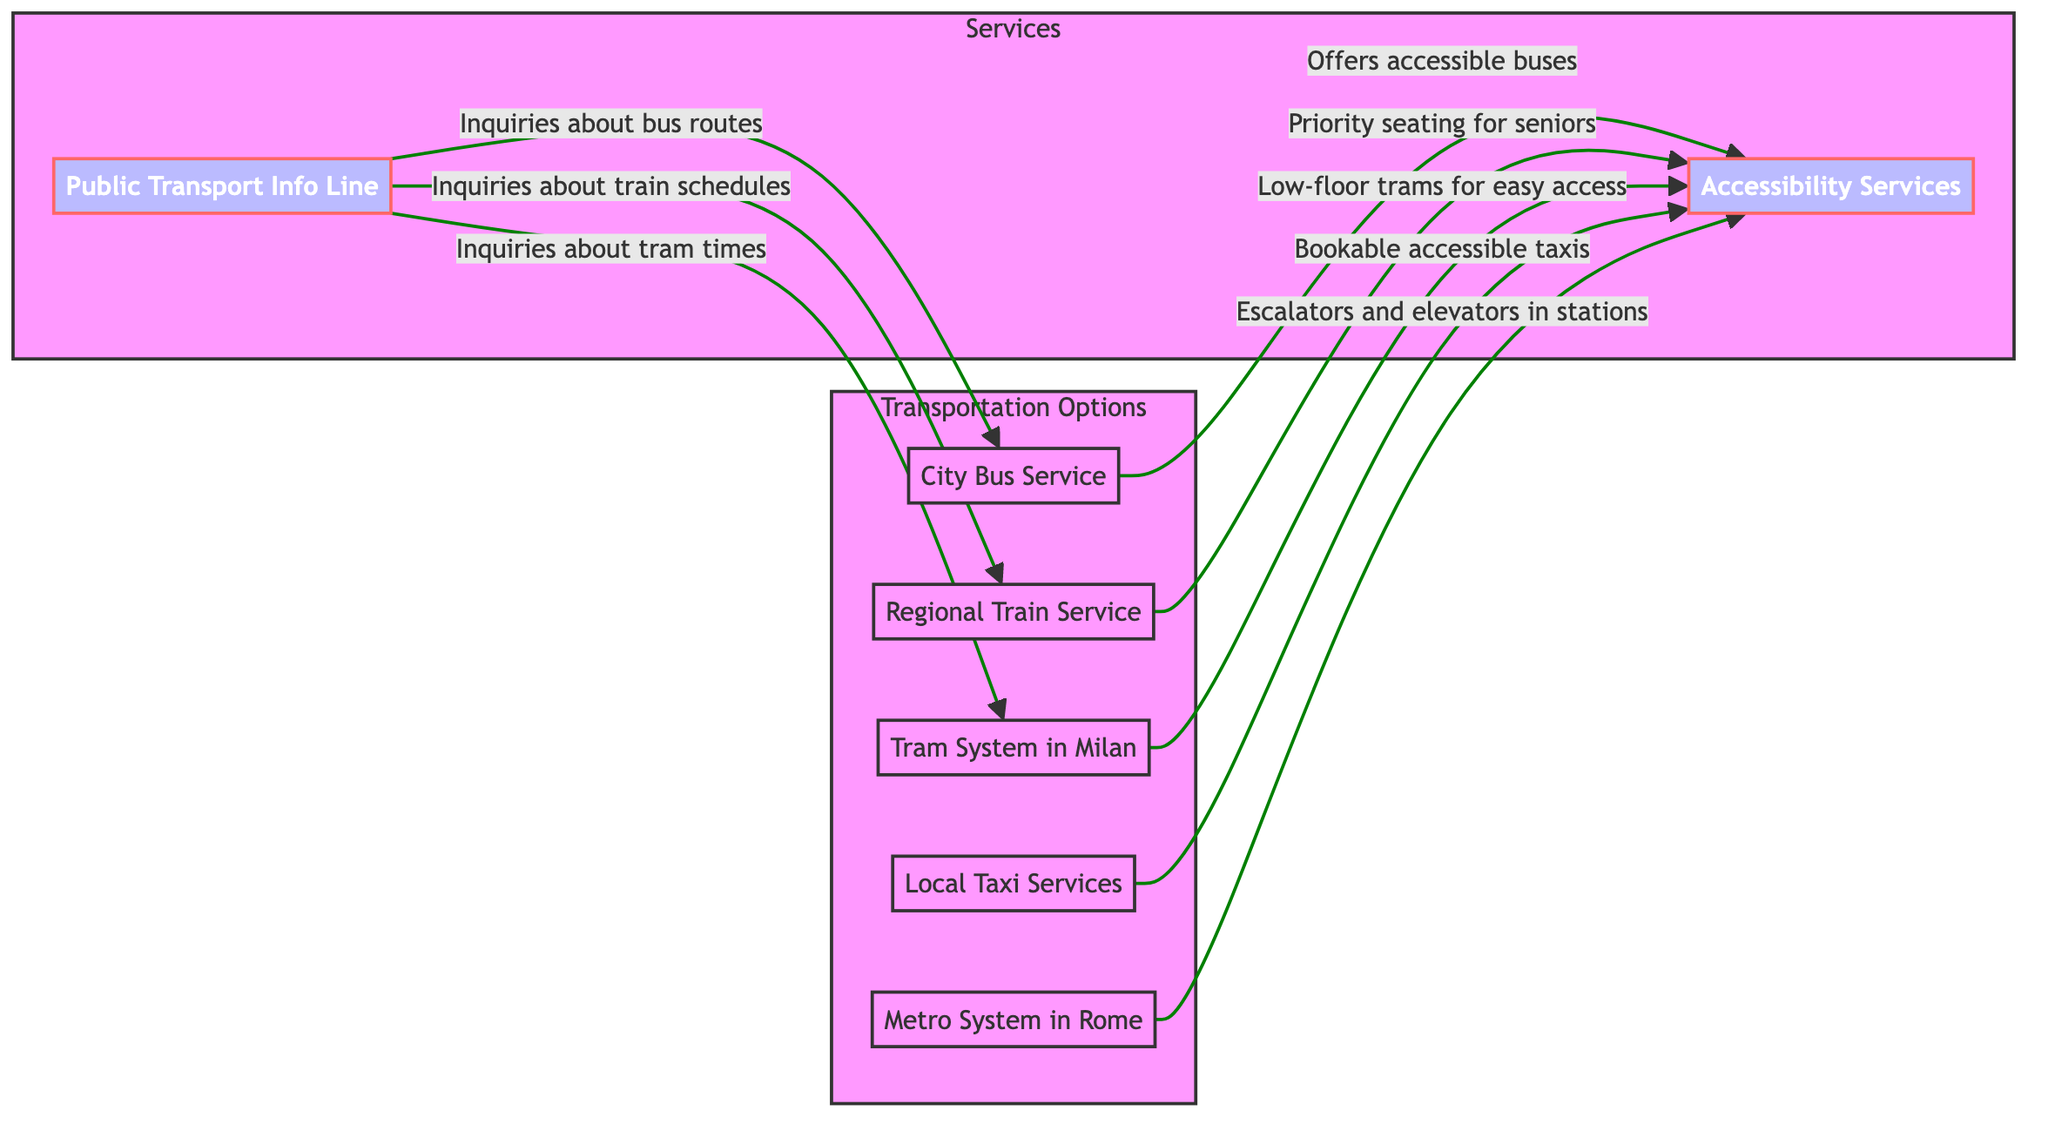What transportation option connects larger cities and towns? The diagram identifies "Regional Train Service" as the node that connects larger cities and towns across regions.
Answer: Regional Train Service How many types of transportation options are shown in the diagram? By counting the nodes related to transportation options, we find five types: City Bus Service, Regional Train Service, Tram System in Milan, Local Taxi Services, and Metro System in Rome.
Answer: 5 What accessibility service is offered by the Local Taxi Services? The diagram states that Local Taxi Services provide bookable accessible taxis, indicating their specific service for senior citizens who may need transportation aid.
Answer: Bookable accessible taxis What does the Public Transport Info Line provide inquiries about? There are three directed edges from the Public Transport Info Line to various transport modes, namely Bus routes, Train schedules, and Tram times, emphasizing its role in providing information.
Answer: Bus routes, Train schedules, Tram times Which transportation option offers low-floor trams for easy access? The directed edge from the Tram System in Milan to Accessibility Services indicates that low-floor trams are provided specifically for ease of access by users, particularly senior citizens.
Answer: Tram System in Milan How many direct relationships exist between transportation options and accessibility services? The diagram shows five directed edges connecting different transportation options to the Accessibility Services node, meaning there are five direct relationships.
Answer: 5 What feature is associated with the Metro System in Rome regarding accessibility? The connection from the Metro System in Rome to Accessibility Services reveals that it includes escalators and elevators in stations, making it more accessible for seniors.
Answer: Escalators and elevators in stations Which transportation option has priority seating for seniors? The directed edge from the Regional Train Service to Accessibility Services explicitly mentions priority seating for seniors, indicating a specific accommodation for elderly passengers.
Answer: Priority seating for seniors 